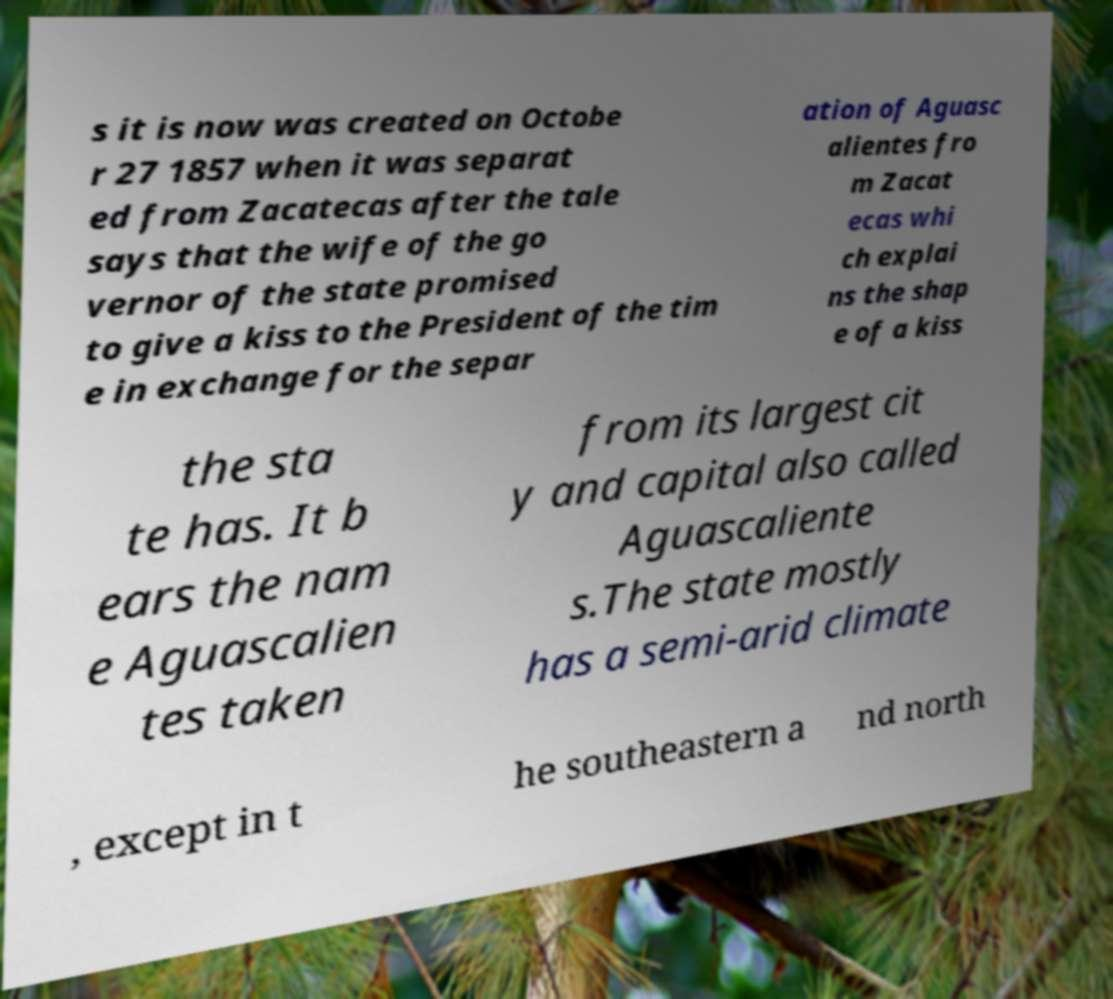I need the written content from this picture converted into text. Can you do that? s it is now was created on Octobe r 27 1857 when it was separat ed from Zacatecas after the tale says that the wife of the go vernor of the state promised to give a kiss to the President of the tim e in exchange for the separ ation of Aguasc alientes fro m Zacat ecas whi ch explai ns the shap e of a kiss the sta te has. It b ears the nam e Aguascalien tes taken from its largest cit y and capital also called Aguascaliente s.The state mostly has a semi-arid climate , except in t he southeastern a nd north 